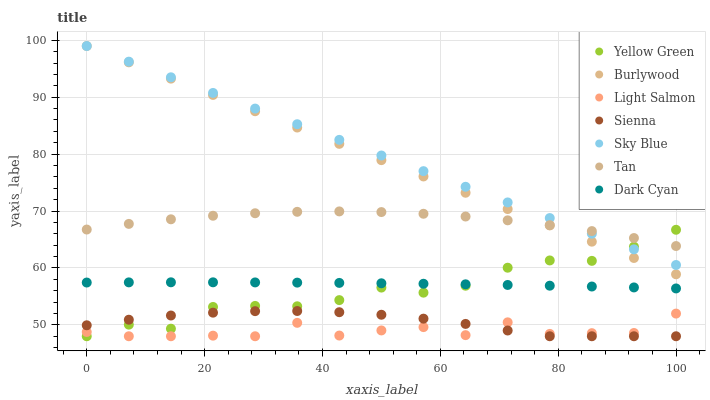Does Light Salmon have the minimum area under the curve?
Answer yes or no. Yes. Does Sky Blue have the maximum area under the curve?
Answer yes or no. Yes. Does Yellow Green have the minimum area under the curve?
Answer yes or no. No. Does Yellow Green have the maximum area under the curve?
Answer yes or no. No. Is Burlywood the smoothest?
Answer yes or no. Yes. Is Light Salmon the roughest?
Answer yes or no. Yes. Is Yellow Green the smoothest?
Answer yes or no. No. Is Yellow Green the roughest?
Answer yes or no. No. Does Light Salmon have the lowest value?
Answer yes or no. Yes. Does Burlywood have the lowest value?
Answer yes or no. No. Does Sky Blue have the highest value?
Answer yes or no. Yes. Does Yellow Green have the highest value?
Answer yes or no. No. Is Light Salmon less than Sky Blue?
Answer yes or no. Yes. Is Tan greater than Dark Cyan?
Answer yes or no. Yes. Does Dark Cyan intersect Yellow Green?
Answer yes or no. Yes. Is Dark Cyan less than Yellow Green?
Answer yes or no. No. Is Dark Cyan greater than Yellow Green?
Answer yes or no. No. Does Light Salmon intersect Sky Blue?
Answer yes or no. No. 